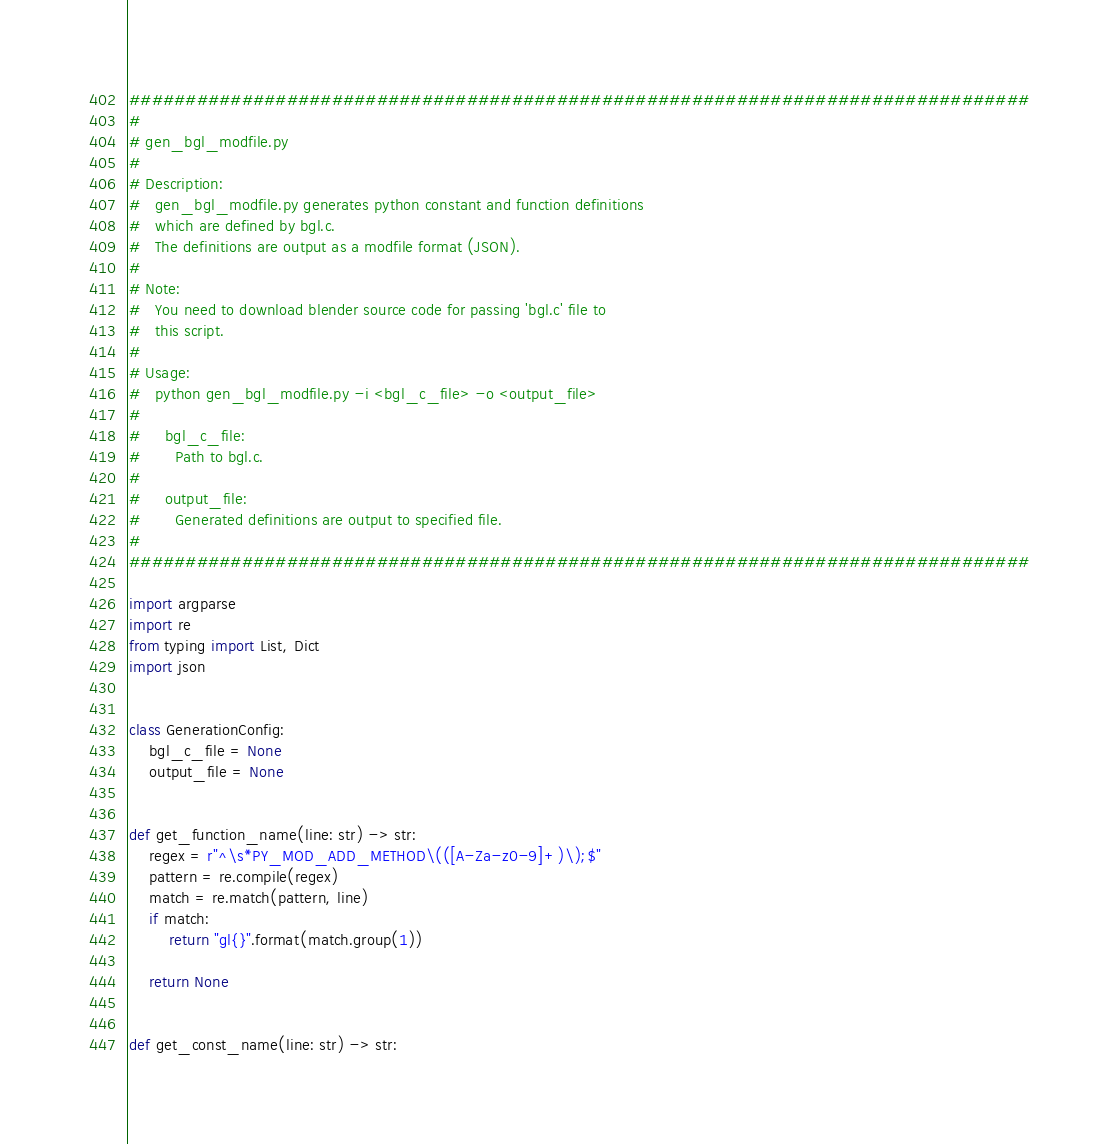<code> <loc_0><loc_0><loc_500><loc_500><_Python_>################################################################################
#
# gen_bgl_modfile.py
#
# Description:
#   gen_bgl_modfile.py generates python constant and function definitions
#   which are defined by bgl.c.
#   The definitions are output as a modfile format (JSON).
#
# Note:
#   You need to download blender source code for passing 'bgl.c' file to
#   this script.
#
# Usage:
#   python gen_bgl_modfile.py -i <bgl_c_file> -o <output_file>
#
#     bgl_c_file:
#       Path to bgl.c.
#
#     output_file:
#       Generated definitions are output to specified file.
#
################################################################################

import argparse
import re
from typing import List, Dict
import json


class GenerationConfig:
    bgl_c_file = None
    output_file = None


def get_function_name(line: str) -> str:
    regex = r"^\s*PY_MOD_ADD_METHOD\(([A-Za-z0-9]+)\);$"
    pattern = re.compile(regex)
    match = re.match(pattern, line)
    if match:
        return "gl{}".format(match.group(1))

    return None


def get_const_name(line: str) -> str:</code> 